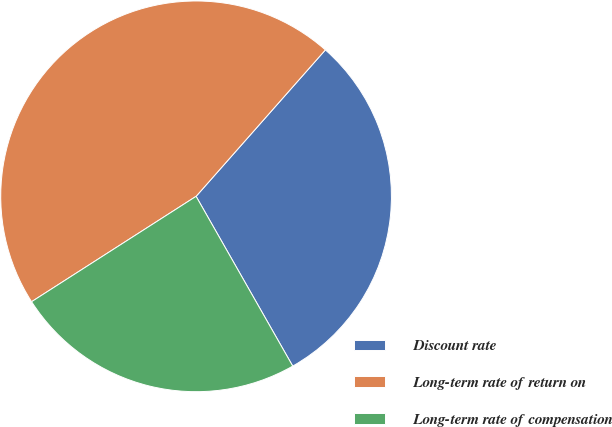Convert chart to OTSL. <chart><loc_0><loc_0><loc_500><loc_500><pie_chart><fcel>Discount rate<fcel>Long-term rate of return on<fcel>Long-term rate of compensation<nl><fcel>30.25%<fcel>45.58%<fcel>24.17%<nl></chart> 